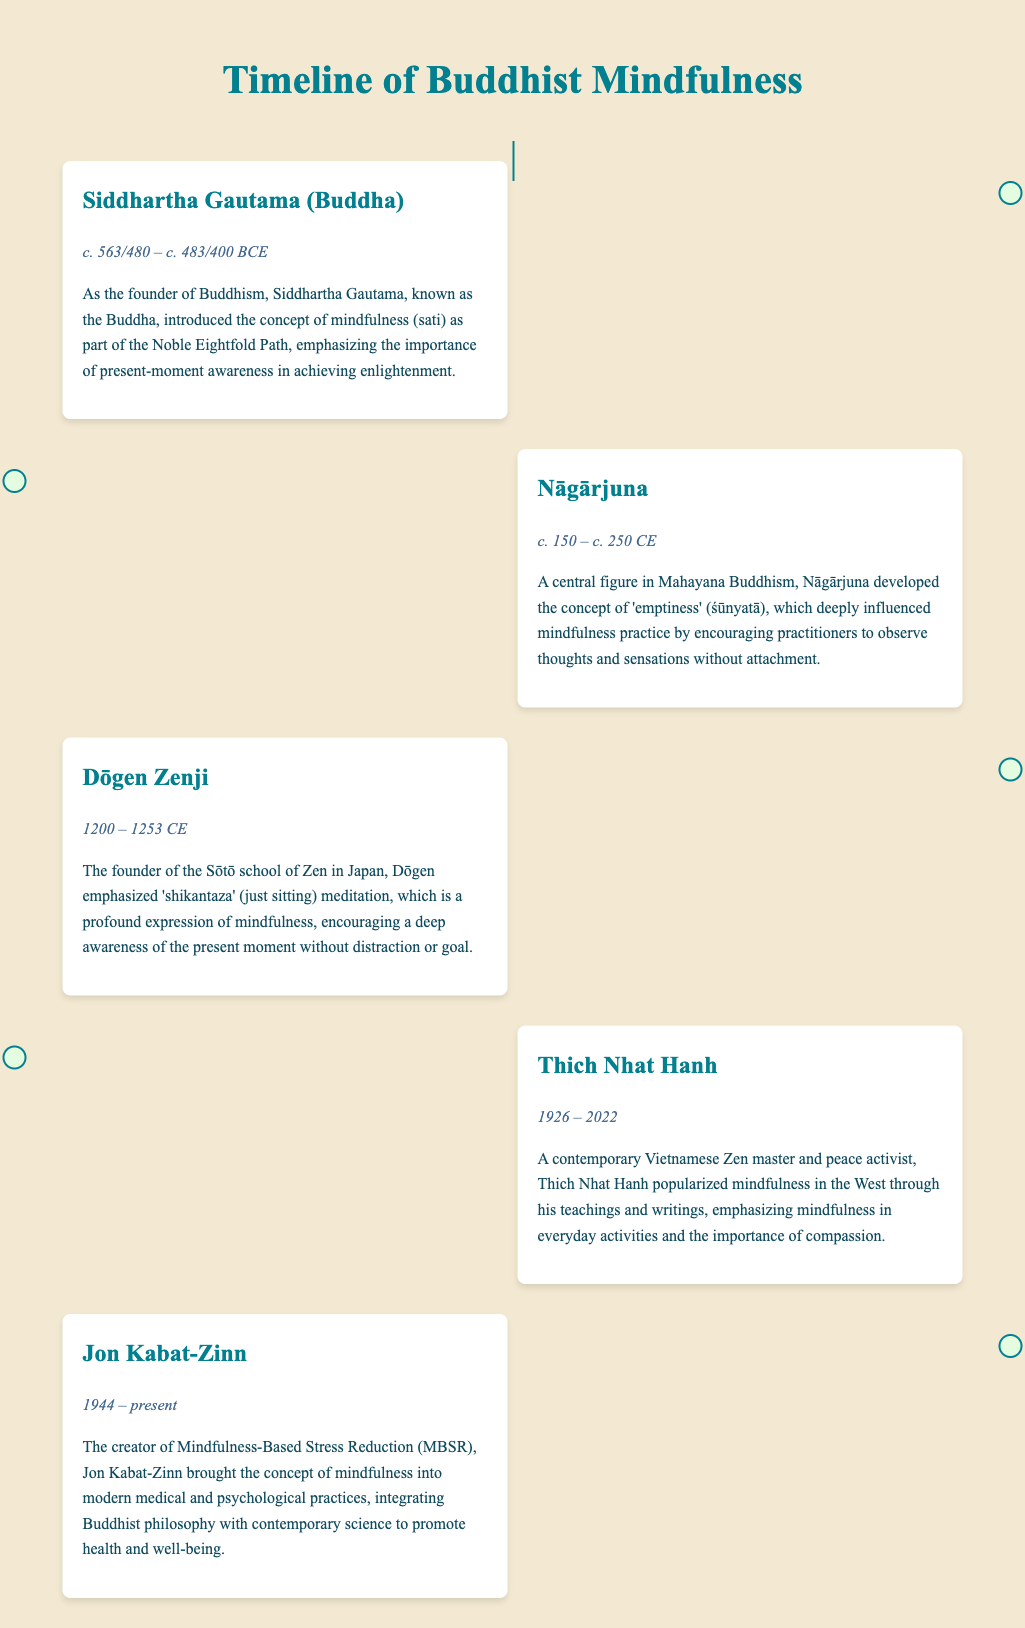What is the period of Siddhartha Gautama? The period of Siddhartha Gautama, known as the Buddha, is indicated as c. 563/480 – c. 483/400 BCE in the document.
Answer: c. 563/480 – c. 483/400 BCE Who developed the concept of 'emptiness'? Nāgārjuna is mentioned in the document as the central figure who developed the concept of 'emptiness' (śūnyatā).
Answer: Nāgārjuna What meditation does Dōgen Zenji emphasize? The document states that Dōgen emphasized 'shikantaza' (just sitting) meditation as a profound expression of mindfulness.
Answer: shikantaza How did Thich Nhat Hanh contribute to mindfulness? Thich Nhat Hanh is noted for popularizing mindfulness in the West through his teachings and writings in the document.
Answer: popularized mindfulness What is the creation attributed to Jon Kabat-Zinn? The document indicates that Jon Kabat-Zinn is the creator of Mindfulness-Based Stress Reduction (MBSR).
Answer: Mindfulness-Based Stress Reduction (MBSR) Which school of Zen did Dōgen Zenji found? The document specifies that Dōgen is the founder of the Sōtō school of Zen in Japan.
Answer: Sōtō What year did Thich Nhat Hanh pass away? According to the document, Thich Nhat Hanh passed away in the year 2022.
Answer: 2022 In what century did Nāgārjuna live? The document presents that Nāgārjuna lived in the 2nd to 3rd century CE.
Answer: 2nd to 3rd century CE 